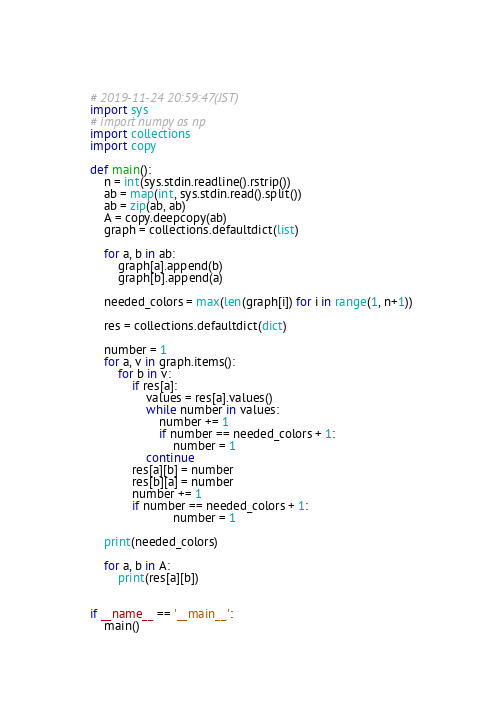<code> <loc_0><loc_0><loc_500><loc_500><_Python_># 2019-11-24 20:59:47(JST)
import sys
# import numpy as np
import collections
import copy

def main():
    n = int(sys.stdin.readline().rstrip())
    ab = map(int, sys.stdin.read().split())
    ab = zip(ab, ab)
    A = copy.deepcopy(ab)
    graph = collections.defaultdict(list)

    for a, b in ab:
        graph[a].append(b)
        graph[b].append(a)

    needed_colors = max(len(graph[i]) for i in range(1, n+1))

    res = collections.defaultdict(dict)

    number = 1
    for a, v in graph.items():
        for b in v:
            if res[a]:
                values = res[a].values()
                while number in values:
                    number += 1
                    if number == needed_colors + 1:
                        number = 1
                continue
            res[a][b] = number
            res[b][a] = number
            number += 1
            if number == needed_colors + 1:
                        number = 1

    print(needed_colors)
    
    for a, b in A:
        print(res[a][b])


if __name__ == '__main__':
    main()
</code> 